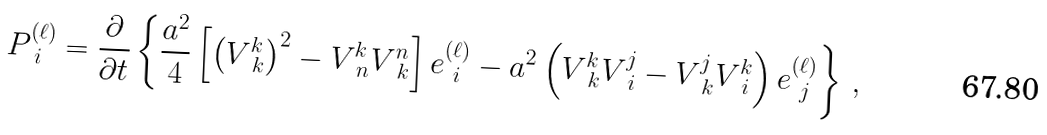Convert formula to latex. <formula><loc_0><loc_0><loc_500><loc_500>P ^ { ( \ell ) } _ { \ i } = \frac { \partial } { \partial t } \left \{ \frac { a ^ { 2 } } { 4 } \left [ \left ( V ^ { k } _ { \ k } \right ) ^ { 2 } - V ^ { k } _ { \ n } V ^ { n } _ { \ k } \right ] e ^ { ( \ell ) } _ { \ i } - a ^ { 2 } \left ( V ^ { k } _ { \ k } V ^ { j } _ { \ i } - V ^ { j } _ { \ k } V ^ { k } _ { \ i } \right ) e ^ { ( \ell ) } _ { \ j } \right \} \, ,</formula> 